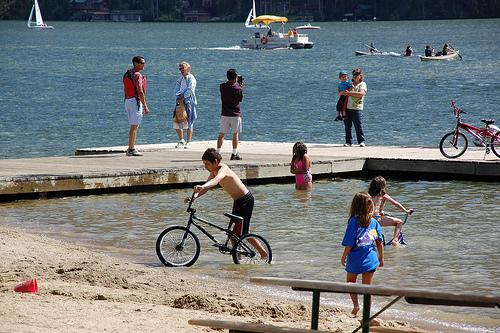Question: what are these people doing?
Choices:
A. Enjoying the lake.
B. Skiing.
C. Swimming.
D. Relaxing on the beach.
Answer with the letter. Answer: A Question: who has a bike in the water?
Choices:
A. A man.
B. A little kid.
C. A shirtless boy.
D. The guy on the right.
Answer with the letter. Answer: C Question: when will the lake rise?
Choices:
A. After a heavy rain.
B. When water is released from the dam.
C. After snow melts.
D. In the spring.
Answer with the letter. Answer: A Question: why is the woman lifting the boy?
Choices:
A. To play with him.
B. To kiss him.
C. To show him off.
D. Photoshoot.
Answer with the letter. Answer: D 